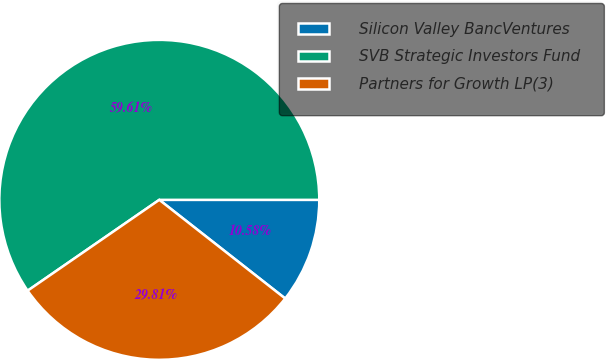Convert chart to OTSL. <chart><loc_0><loc_0><loc_500><loc_500><pie_chart><fcel>Silicon Valley BancVentures<fcel>SVB Strategic Investors Fund<fcel>Partners for Growth LP(3)<nl><fcel>10.58%<fcel>59.62%<fcel>29.81%<nl></chart> 